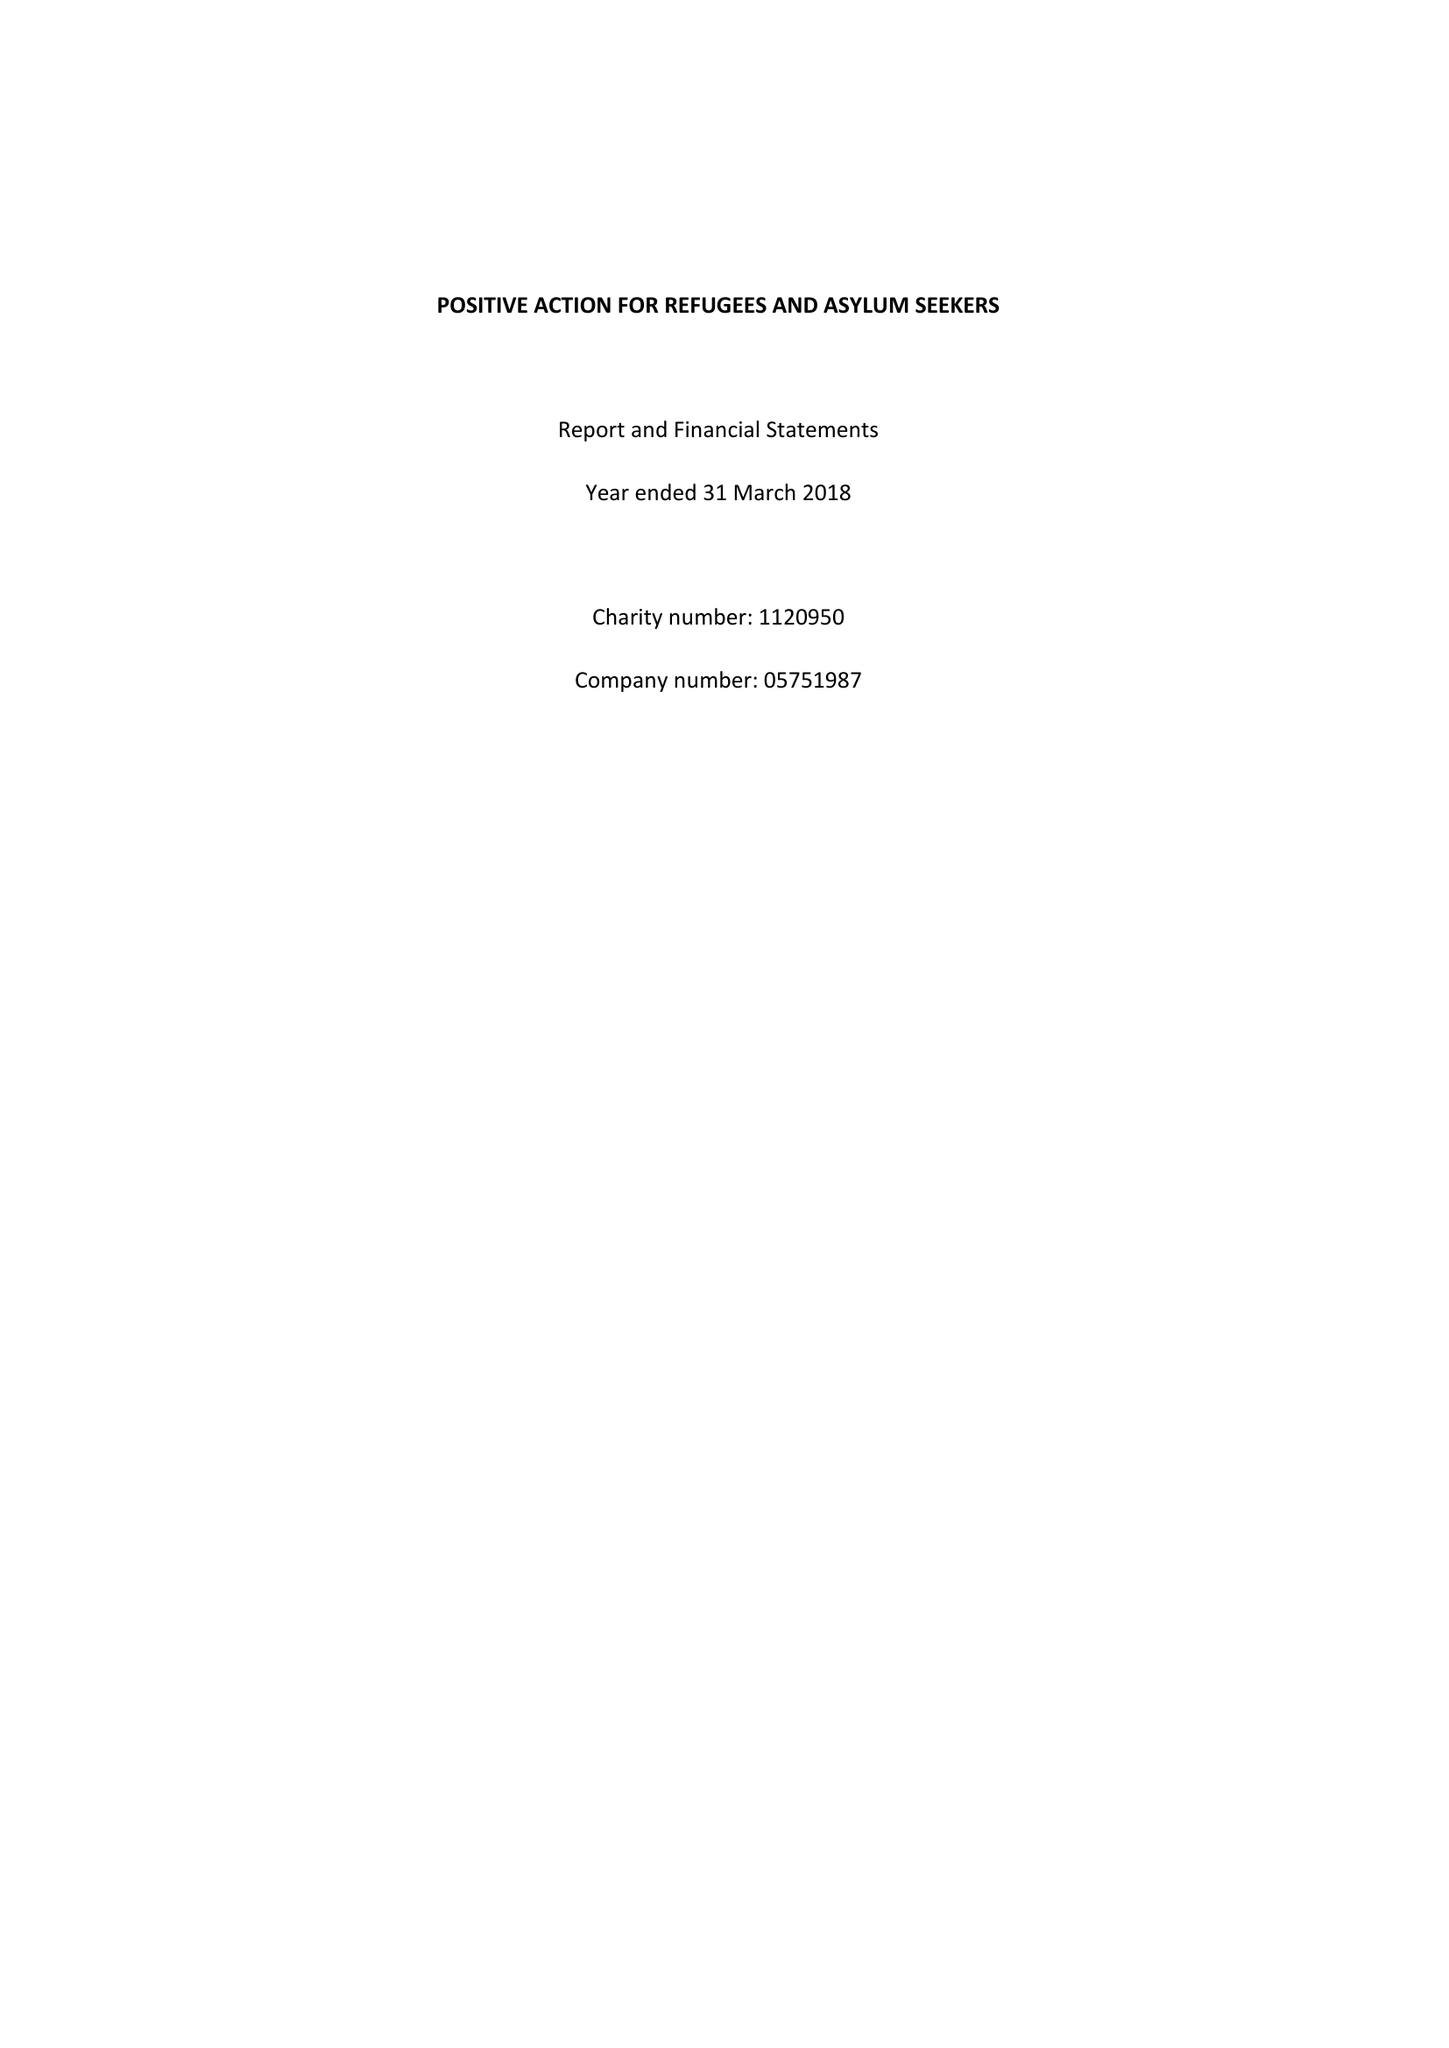What is the value for the address__street_line?
Answer the question using a single word or phrase. 26 ROUNDHAY ROAD 